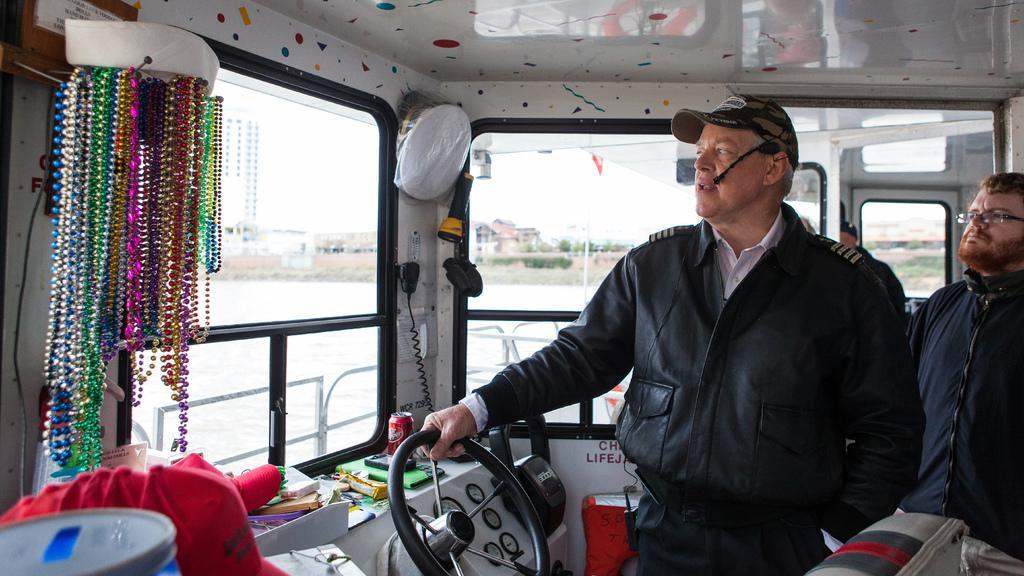Please provide a concise description of this image. In this image we can see a ship on the water, in the ship, we can see two persons, meters, tins and some other objects, also we can see a few buildings, trees and the sky. 